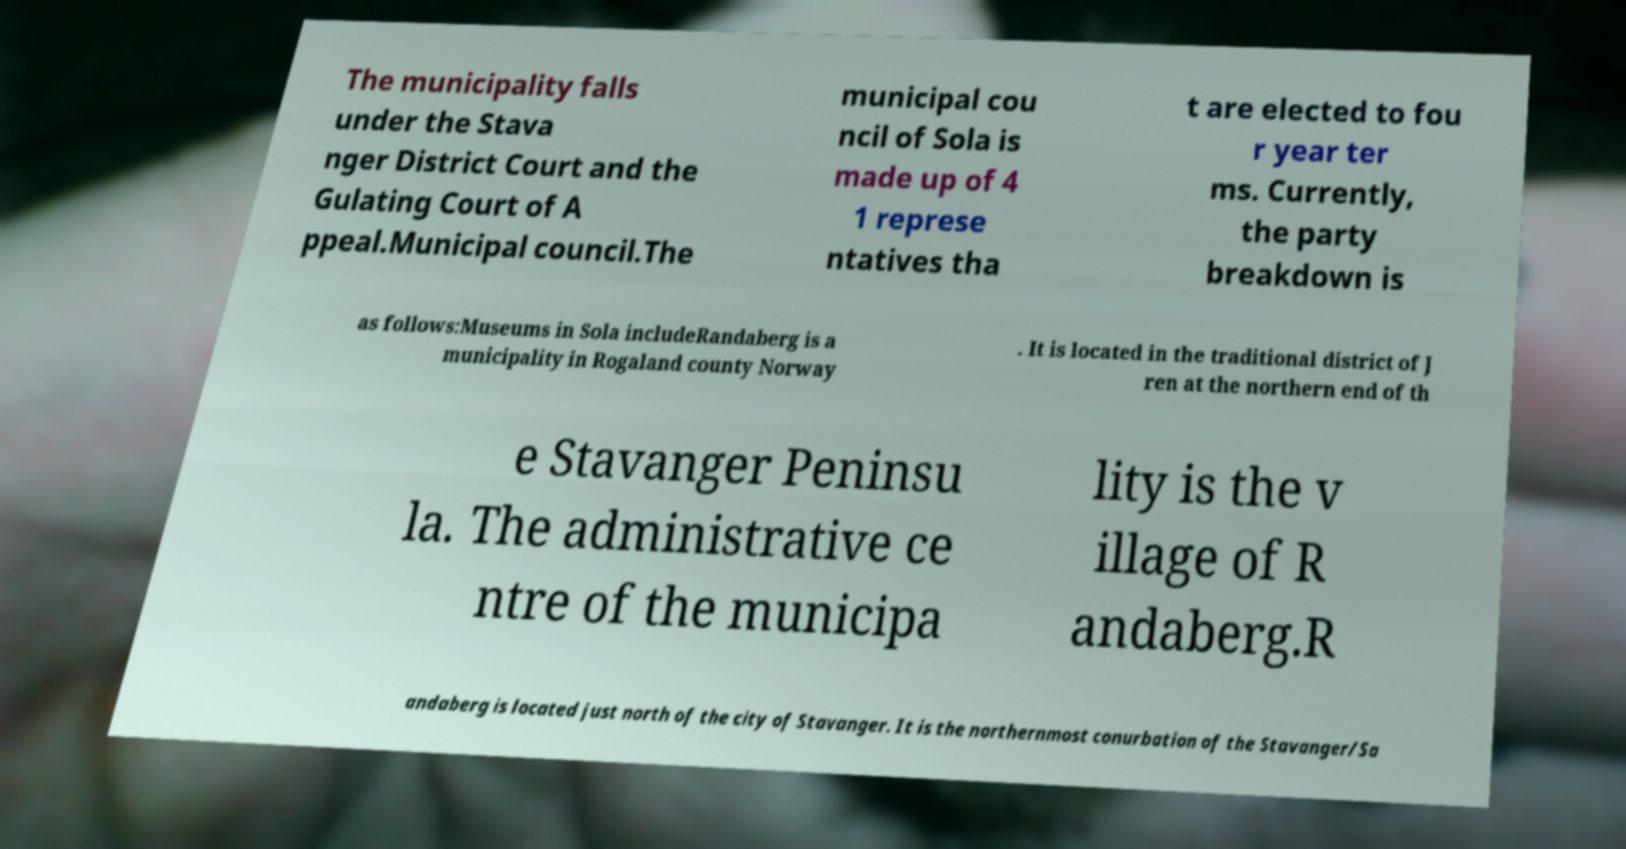For documentation purposes, I need the text within this image transcribed. Could you provide that? The municipality falls under the Stava nger District Court and the Gulating Court of A ppeal.Municipal council.The municipal cou ncil of Sola is made up of 4 1 represe ntatives tha t are elected to fou r year ter ms. Currently, the party breakdown is as follows:Museums in Sola includeRandaberg is a municipality in Rogaland county Norway . It is located in the traditional district of J ren at the northern end of th e Stavanger Peninsu la. The administrative ce ntre of the municipa lity is the v illage of R andaberg.R andaberg is located just north of the city of Stavanger. It is the northernmost conurbation of the Stavanger/Sa 